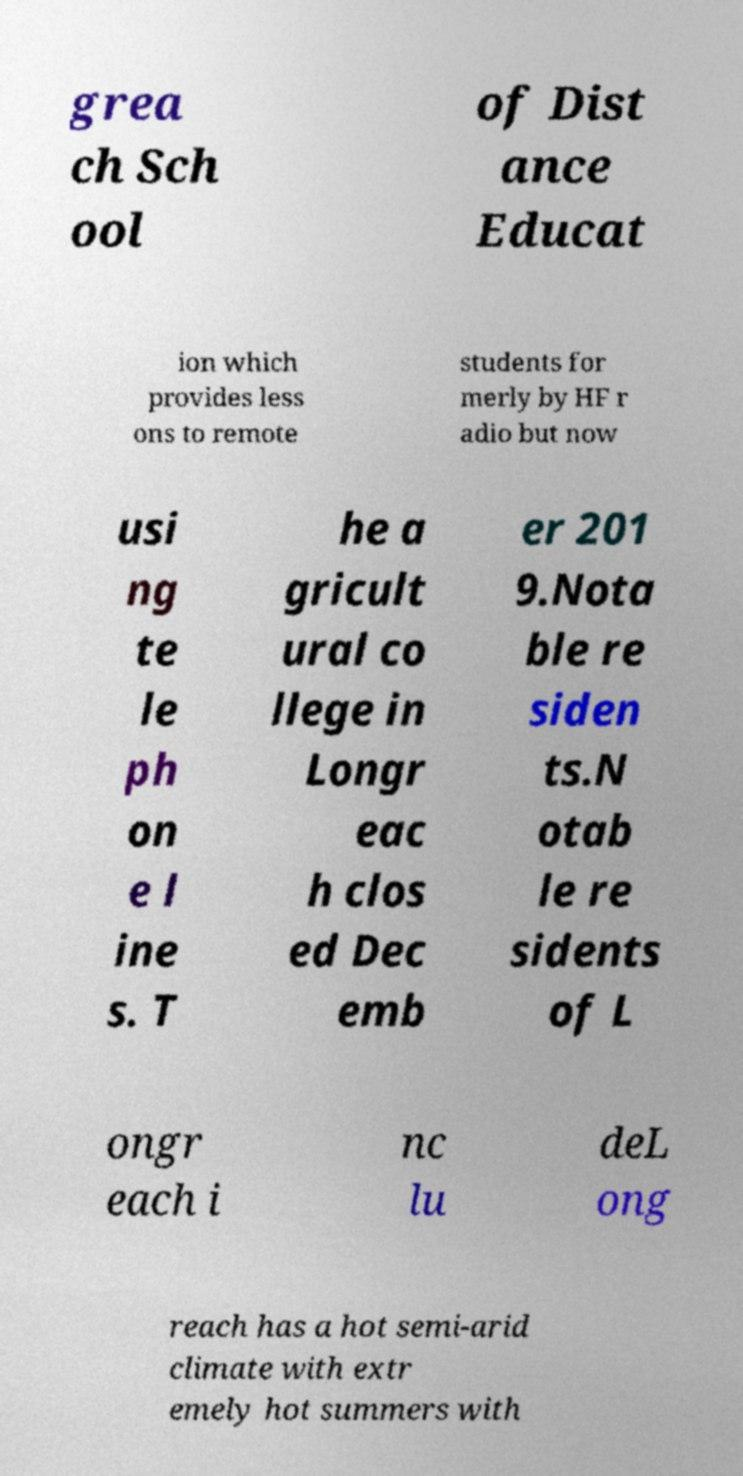Could you assist in decoding the text presented in this image and type it out clearly? grea ch Sch ool of Dist ance Educat ion which provides less ons to remote students for merly by HF r adio but now usi ng te le ph on e l ine s. T he a gricult ural co llege in Longr eac h clos ed Dec emb er 201 9.Nota ble re siden ts.N otab le re sidents of L ongr each i nc lu deL ong reach has a hot semi-arid climate with extr emely hot summers with 